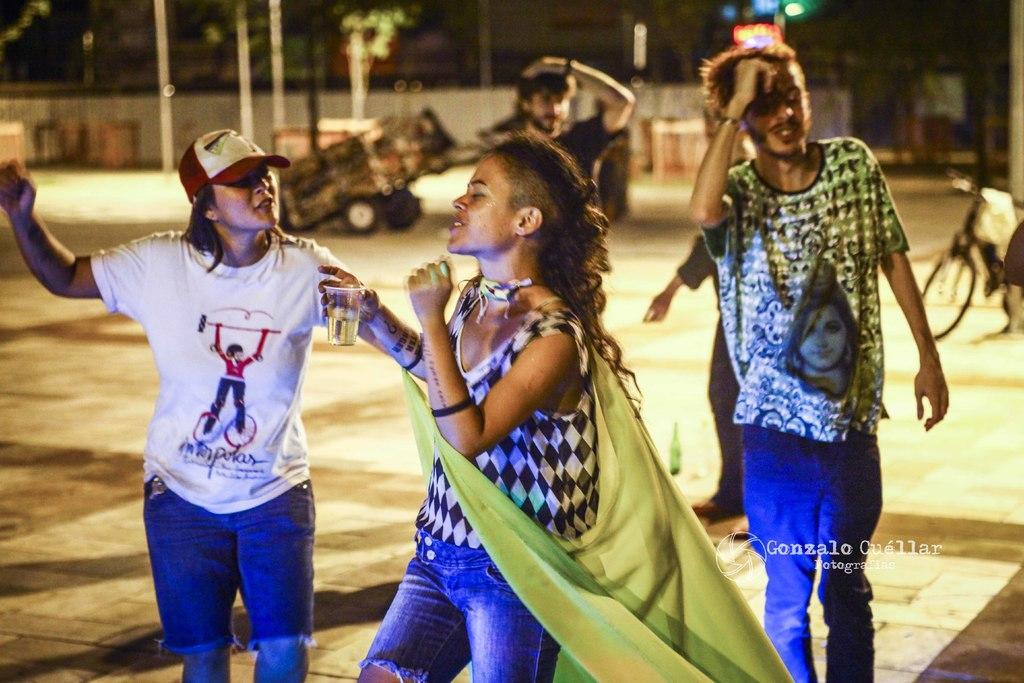Can you describe this image briefly? In this picture we can see few persons. There is a bicycle and a vehicle. In the background there are poles, trees, light, and wall. 